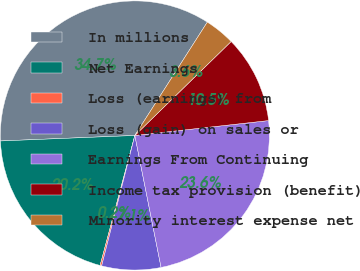Convert chart to OTSL. <chart><loc_0><loc_0><loc_500><loc_500><pie_chart><fcel>In millions<fcel>Net Earnings<fcel>Loss (earnings) from<fcel>Loss (gain) on sales or<fcel>Earnings From Continuing<fcel>Income tax provision (benefit)<fcel>Minority interest expense net<nl><fcel>34.7%<fcel>20.19%<fcel>0.19%<fcel>7.09%<fcel>23.64%<fcel>10.54%<fcel>3.64%<nl></chart> 